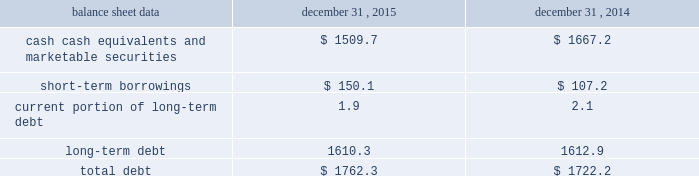Management 2019s discussion and analysis of financial condition and results of operations 2013 ( continued ) ( amounts in millions , except per share amounts ) financing activities net cash used in financing activities during 2015 primarily related to the repurchase of our common stock and payment of dividends .
We repurchased 13.6 shares of our common stock for an aggregate cost of $ 285.2 , including fees , and made dividend payments of $ 195.5 on our common stock .
Net cash used in financing activities during 2014 primarily related to the purchase of long-term debt , the repurchase of our common stock and payment of dividends .
We redeemed all $ 350.0 in aggregate principal amount of our 6.25% ( 6.25 % ) notes , repurchased 14.9 shares of our common stock for an aggregate cost of $ 275.1 , including fees , and made dividend payments of $ 159.0 on our common stock .
This was offset by the issuance of $ 500.0 in aggregate principal amount of our 4.20% ( 4.20 % ) notes .
Foreign exchange rate changes the effect of foreign exchange rate changes on cash and cash equivalents included in the consolidated statements of cash flows resulted in a decrease of $ 156.1 in 2015 .
The decrease was primarily a result of the u.s .
Dollar being stronger than several foreign currencies , including the australian dollar , brazilian real , canadian dollar , euro and south african rand as of december 31 , 2015 compared to december 31 , 2014 .
The effect of foreign exchange rate changes on cash and cash equivalents included in the consolidated statements of cash flows resulted in a decrease of $ 101.0 in 2014 .
The decrease was primarily a result of the u.s .
Dollar being stronger than several foreign currencies , including the australian dollar , brazilian real , canadian dollar and euro as of december 31 , 2014 compared to december 31 , 2013. .
Liquidity outlook we expect our cash flow from operations , cash and cash equivalents to be sufficient to meet our anticipated operating requirements at a minimum for the next twelve months .
We also have a committed corporate credit facility as well as uncommitted facilities available to support our operating needs .
We continue to maintain a disciplined approach to managing liquidity , with flexibility over significant uses of cash , including our capital expenditures , cash used for new acquisitions , our common stock repurchase program and our common stock dividends .
From time to time , we evaluate market conditions and financing alternatives for opportunities to raise additional funds or otherwise improve our liquidity profile , enhance our financial flexibility and manage market risk .
Our ability to access the capital markets depends on a number of factors , which include those specific to us , such as our credit rating , and those related to the financial markets , such as the amount or terms of available credit .
There can be no guarantee that we would be able to access new sources of liquidity on commercially reasonable terms , or at all .
Funding requirements our most significant funding requirements include our operations , non-cancelable operating lease obligations , capital expenditures , acquisitions , common stock dividends , taxes , debt service and contributions to pension and postretirement plans .
Additionally , we may be required to make payments to minority shareholders in certain subsidiaries if they exercise their options to sell us their equity interests. .
What is the percentage of total debt from 2014-2015 that was long-term debt? 
Computations: (((1610.3 + 1612.9) / (1762.3 + 1722.2)) * 100)
Answer: 92.50108. 